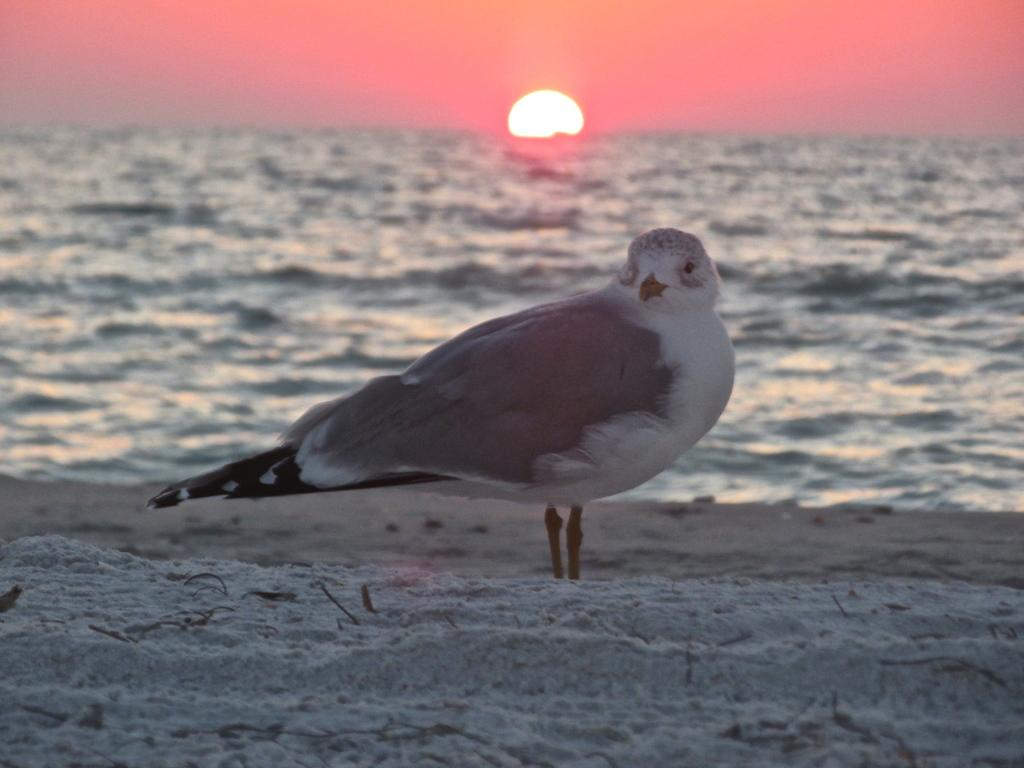What type of animal is in the image? There is a bird in the image. What is the bird standing on? The bird is standing on sand. What else can be seen in the image besides the bird? Water is visible in the image. What is visible in the background of the image? The sky is visible in the background of the image. What type of scarf is the bird wearing in the image? There is no scarf present in the image; the bird is not wearing any clothing. 